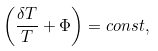<formula> <loc_0><loc_0><loc_500><loc_500>\left ( \frac { \delta T } { T } + \Phi \right ) = c o n s t ,</formula> 